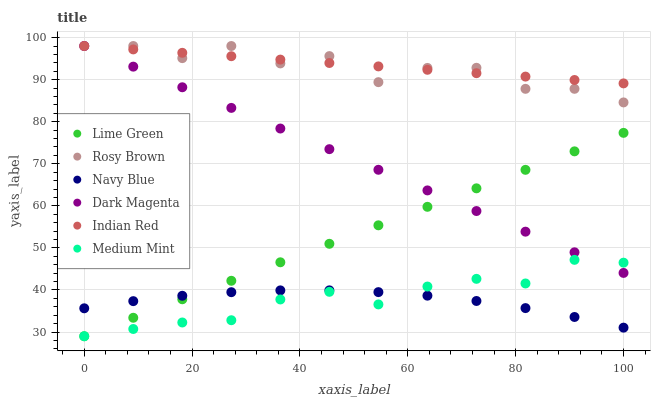Does Navy Blue have the minimum area under the curve?
Answer yes or no. Yes. Does Indian Red have the maximum area under the curve?
Answer yes or no. Yes. Does Dark Magenta have the minimum area under the curve?
Answer yes or no. No. Does Dark Magenta have the maximum area under the curve?
Answer yes or no. No. Is Lime Green the smoothest?
Answer yes or no. Yes. Is Rosy Brown the roughest?
Answer yes or no. Yes. Is Dark Magenta the smoothest?
Answer yes or no. No. Is Dark Magenta the roughest?
Answer yes or no. No. Does Medium Mint have the lowest value?
Answer yes or no. Yes. Does Dark Magenta have the lowest value?
Answer yes or no. No. Does Indian Red have the highest value?
Answer yes or no. Yes. Does Navy Blue have the highest value?
Answer yes or no. No. Is Medium Mint less than Indian Red?
Answer yes or no. Yes. Is Dark Magenta greater than Navy Blue?
Answer yes or no. Yes. Does Lime Green intersect Dark Magenta?
Answer yes or no. Yes. Is Lime Green less than Dark Magenta?
Answer yes or no. No. Is Lime Green greater than Dark Magenta?
Answer yes or no. No. Does Medium Mint intersect Indian Red?
Answer yes or no. No. 